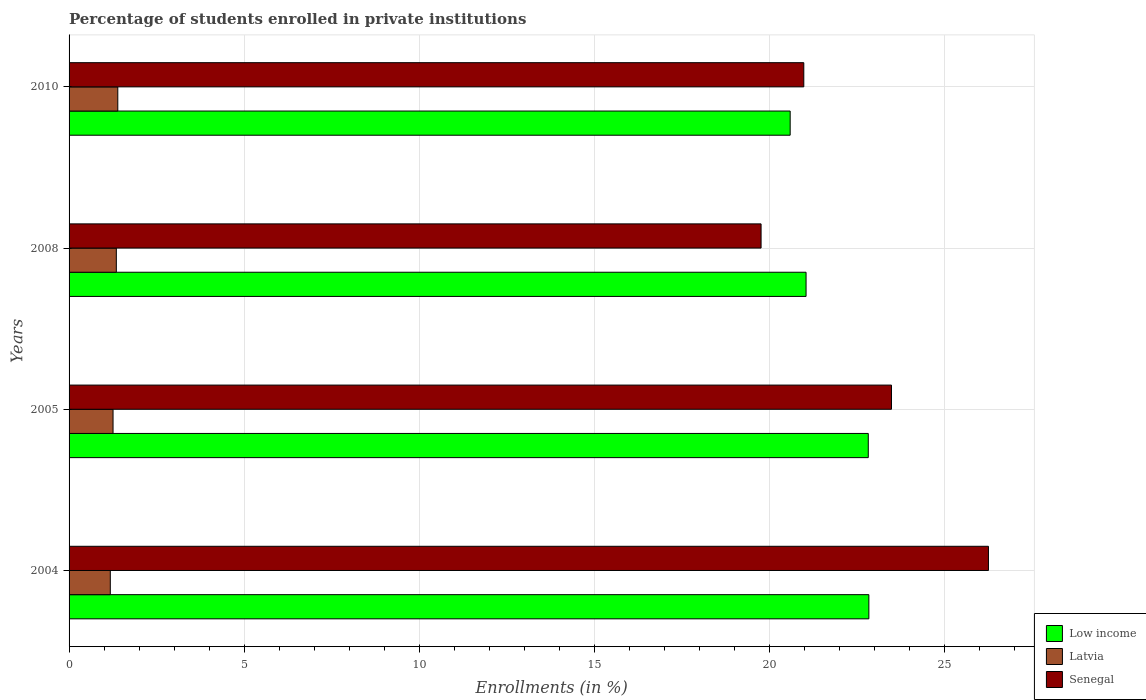How many groups of bars are there?
Offer a terse response. 4. Are the number of bars per tick equal to the number of legend labels?
Ensure brevity in your answer.  Yes. Are the number of bars on each tick of the Y-axis equal?
Offer a very short reply. Yes. What is the label of the 3rd group of bars from the top?
Provide a short and direct response. 2005. What is the percentage of trained teachers in Low income in 2008?
Your response must be concise. 21.04. Across all years, what is the maximum percentage of trained teachers in Low income?
Make the answer very short. 22.83. Across all years, what is the minimum percentage of trained teachers in Low income?
Offer a terse response. 20.59. What is the total percentage of trained teachers in Senegal in the graph?
Your answer should be compact. 90.46. What is the difference between the percentage of trained teachers in Latvia in 2004 and that in 2010?
Provide a succinct answer. -0.21. What is the difference between the percentage of trained teachers in Senegal in 2005 and the percentage of trained teachers in Low income in 2008?
Your answer should be very brief. 2.44. What is the average percentage of trained teachers in Senegal per year?
Your answer should be compact. 22.61. In the year 2005, what is the difference between the percentage of trained teachers in Low income and percentage of trained teachers in Senegal?
Provide a short and direct response. -0.66. What is the ratio of the percentage of trained teachers in Low income in 2005 to that in 2008?
Your answer should be very brief. 1.08. Is the difference between the percentage of trained teachers in Low income in 2004 and 2008 greater than the difference between the percentage of trained teachers in Senegal in 2004 and 2008?
Offer a very short reply. No. What is the difference between the highest and the second highest percentage of trained teachers in Senegal?
Make the answer very short. 2.77. What is the difference between the highest and the lowest percentage of trained teachers in Low income?
Your answer should be very brief. 2.25. What does the 3rd bar from the bottom in 2005 represents?
Your answer should be compact. Senegal. Is it the case that in every year, the sum of the percentage of trained teachers in Senegal and percentage of trained teachers in Latvia is greater than the percentage of trained teachers in Low income?
Provide a succinct answer. Yes. How many years are there in the graph?
Offer a very short reply. 4. What is the difference between two consecutive major ticks on the X-axis?
Ensure brevity in your answer.  5. Are the values on the major ticks of X-axis written in scientific E-notation?
Ensure brevity in your answer.  No. Does the graph contain any zero values?
Offer a very short reply. No. Does the graph contain grids?
Provide a succinct answer. Yes. What is the title of the graph?
Offer a terse response. Percentage of students enrolled in private institutions. What is the label or title of the X-axis?
Give a very brief answer. Enrollments (in %). What is the Enrollments (in %) in Low income in 2004?
Ensure brevity in your answer.  22.83. What is the Enrollments (in %) of Latvia in 2004?
Provide a short and direct response. 1.18. What is the Enrollments (in %) in Senegal in 2004?
Provide a short and direct response. 26.25. What is the Enrollments (in %) of Low income in 2005?
Offer a very short reply. 22.82. What is the Enrollments (in %) in Latvia in 2005?
Your response must be concise. 1.26. What is the Enrollments (in %) in Senegal in 2005?
Your response must be concise. 23.48. What is the Enrollments (in %) of Low income in 2008?
Make the answer very short. 21.04. What is the Enrollments (in %) of Latvia in 2008?
Offer a very short reply. 1.35. What is the Enrollments (in %) in Senegal in 2008?
Your answer should be very brief. 19.76. What is the Enrollments (in %) in Low income in 2010?
Offer a very short reply. 20.59. What is the Enrollments (in %) in Latvia in 2010?
Give a very brief answer. 1.39. What is the Enrollments (in %) in Senegal in 2010?
Your response must be concise. 20.98. Across all years, what is the maximum Enrollments (in %) in Low income?
Your answer should be compact. 22.83. Across all years, what is the maximum Enrollments (in %) in Latvia?
Your answer should be compact. 1.39. Across all years, what is the maximum Enrollments (in %) in Senegal?
Provide a succinct answer. 26.25. Across all years, what is the minimum Enrollments (in %) in Low income?
Provide a succinct answer. 20.59. Across all years, what is the minimum Enrollments (in %) of Latvia?
Your answer should be compact. 1.18. Across all years, what is the minimum Enrollments (in %) in Senegal?
Ensure brevity in your answer.  19.76. What is the total Enrollments (in %) of Low income in the graph?
Keep it short and to the point. 87.28. What is the total Enrollments (in %) in Latvia in the graph?
Provide a short and direct response. 5.17. What is the total Enrollments (in %) of Senegal in the graph?
Provide a short and direct response. 90.46. What is the difference between the Enrollments (in %) of Low income in 2004 and that in 2005?
Make the answer very short. 0.02. What is the difference between the Enrollments (in %) in Latvia in 2004 and that in 2005?
Offer a terse response. -0.08. What is the difference between the Enrollments (in %) in Senegal in 2004 and that in 2005?
Provide a succinct answer. 2.77. What is the difference between the Enrollments (in %) in Low income in 2004 and that in 2008?
Provide a succinct answer. 1.79. What is the difference between the Enrollments (in %) in Latvia in 2004 and that in 2008?
Offer a terse response. -0.17. What is the difference between the Enrollments (in %) in Senegal in 2004 and that in 2008?
Keep it short and to the point. 6.49. What is the difference between the Enrollments (in %) in Low income in 2004 and that in 2010?
Give a very brief answer. 2.25. What is the difference between the Enrollments (in %) of Latvia in 2004 and that in 2010?
Your answer should be very brief. -0.21. What is the difference between the Enrollments (in %) in Senegal in 2004 and that in 2010?
Provide a short and direct response. 5.27. What is the difference between the Enrollments (in %) of Low income in 2005 and that in 2008?
Keep it short and to the point. 1.78. What is the difference between the Enrollments (in %) in Latvia in 2005 and that in 2008?
Your answer should be compact. -0.09. What is the difference between the Enrollments (in %) of Senegal in 2005 and that in 2008?
Give a very brief answer. 3.72. What is the difference between the Enrollments (in %) of Low income in 2005 and that in 2010?
Offer a very short reply. 2.23. What is the difference between the Enrollments (in %) of Latvia in 2005 and that in 2010?
Provide a short and direct response. -0.14. What is the difference between the Enrollments (in %) of Senegal in 2005 and that in 2010?
Your answer should be very brief. 2.5. What is the difference between the Enrollments (in %) of Low income in 2008 and that in 2010?
Give a very brief answer. 0.45. What is the difference between the Enrollments (in %) of Latvia in 2008 and that in 2010?
Your answer should be very brief. -0.04. What is the difference between the Enrollments (in %) of Senegal in 2008 and that in 2010?
Offer a terse response. -1.22. What is the difference between the Enrollments (in %) of Low income in 2004 and the Enrollments (in %) of Latvia in 2005?
Provide a short and direct response. 21.58. What is the difference between the Enrollments (in %) in Low income in 2004 and the Enrollments (in %) in Senegal in 2005?
Provide a succinct answer. -0.65. What is the difference between the Enrollments (in %) of Latvia in 2004 and the Enrollments (in %) of Senegal in 2005?
Your response must be concise. -22.3. What is the difference between the Enrollments (in %) of Low income in 2004 and the Enrollments (in %) of Latvia in 2008?
Provide a succinct answer. 21.48. What is the difference between the Enrollments (in %) of Low income in 2004 and the Enrollments (in %) of Senegal in 2008?
Your answer should be very brief. 3.08. What is the difference between the Enrollments (in %) of Latvia in 2004 and the Enrollments (in %) of Senegal in 2008?
Provide a short and direct response. -18.58. What is the difference between the Enrollments (in %) of Low income in 2004 and the Enrollments (in %) of Latvia in 2010?
Your answer should be very brief. 21.44. What is the difference between the Enrollments (in %) in Low income in 2004 and the Enrollments (in %) in Senegal in 2010?
Give a very brief answer. 1.86. What is the difference between the Enrollments (in %) of Latvia in 2004 and the Enrollments (in %) of Senegal in 2010?
Keep it short and to the point. -19.8. What is the difference between the Enrollments (in %) in Low income in 2005 and the Enrollments (in %) in Latvia in 2008?
Your response must be concise. 21.47. What is the difference between the Enrollments (in %) of Low income in 2005 and the Enrollments (in %) of Senegal in 2008?
Provide a succinct answer. 3.06. What is the difference between the Enrollments (in %) in Latvia in 2005 and the Enrollments (in %) in Senegal in 2008?
Your answer should be very brief. -18.5. What is the difference between the Enrollments (in %) of Low income in 2005 and the Enrollments (in %) of Latvia in 2010?
Offer a terse response. 21.43. What is the difference between the Enrollments (in %) of Low income in 2005 and the Enrollments (in %) of Senegal in 2010?
Provide a succinct answer. 1.84. What is the difference between the Enrollments (in %) in Latvia in 2005 and the Enrollments (in %) in Senegal in 2010?
Ensure brevity in your answer.  -19.72. What is the difference between the Enrollments (in %) of Low income in 2008 and the Enrollments (in %) of Latvia in 2010?
Keep it short and to the point. 19.65. What is the difference between the Enrollments (in %) in Low income in 2008 and the Enrollments (in %) in Senegal in 2010?
Your answer should be compact. 0.06. What is the difference between the Enrollments (in %) of Latvia in 2008 and the Enrollments (in %) of Senegal in 2010?
Give a very brief answer. -19.63. What is the average Enrollments (in %) of Low income per year?
Provide a succinct answer. 21.82. What is the average Enrollments (in %) of Latvia per year?
Make the answer very short. 1.29. What is the average Enrollments (in %) in Senegal per year?
Provide a succinct answer. 22.61. In the year 2004, what is the difference between the Enrollments (in %) in Low income and Enrollments (in %) in Latvia?
Offer a very short reply. 21.66. In the year 2004, what is the difference between the Enrollments (in %) of Low income and Enrollments (in %) of Senegal?
Keep it short and to the point. -3.41. In the year 2004, what is the difference between the Enrollments (in %) in Latvia and Enrollments (in %) in Senegal?
Your answer should be very brief. -25.07. In the year 2005, what is the difference between the Enrollments (in %) of Low income and Enrollments (in %) of Latvia?
Your answer should be compact. 21.56. In the year 2005, what is the difference between the Enrollments (in %) in Low income and Enrollments (in %) in Senegal?
Ensure brevity in your answer.  -0.66. In the year 2005, what is the difference between the Enrollments (in %) of Latvia and Enrollments (in %) of Senegal?
Offer a very short reply. -22.22. In the year 2008, what is the difference between the Enrollments (in %) in Low income and Enrollments (in %) in Latvia?
Offer a terse response. 19.69. In the year 2008, what is the difference between the Enrollments (in %) of Low income and Enrollments (in %) of Senegal?
Ensure brevity in your answer.  1.28. In the year 2008, what is the difference between the Enrollments (in %) in Latvia and Enrollments (in %) in Senegal?
Provide a short and direct response. -18.41. In the year 2010, what is the difference between the Enrollments (in %) of Low income and Enrollments (in %) of Latvia?
Ensure brevity in your answer.  19.2. In the year 2010, what is the difference between the Enrollments (in %) in Low income and Enrollments (in %) in Senegal?
Provide a succinct answer. -0.39. In the year 2010, what is the difference between the Enrollments (in %) in Latvia and Enrollments (in %) in Senegal?
Offer a terse response. -19.58. What is the ratio of the Enrollments (in %) in Latvia in 2004 to that in 2005?
Your response must be concise. 0.94. What is the ratio of the Enrollments (in %) in Senegal in 2004 to that in 2005?
Give a very brief answer. 1.12. What is the ratio of the Enrollments (in %) of Low income in 2004 to that in 2008?
Keep it short and to the point. 1.09. What is the ratio of the Enrollments (in %) of Latvia in 2004 to that in 2008?
Offer a very short reply. 0.87. What is the ratio of the Enrollments (in %) in Senegal in 2004 to that in 2008?
Keep it short and to the point. 1.33. What is the ratio of the Enrollments (in %) of Low income in 2004 to that in 2010?
Your answer should be compact. 1.11. What is the ratio of the Enrollments (in %) in Latvia in 2004 to that in 2010?
Your response must be concise. 0.85. What is the ratio of the Enrollments (in %) in Senegal in 2004 to that in 2010?
Provide a succinct answer. 1.25. What is the ratio of the Enrollments (in %) of Low income in 2005 to that in 2008?
Offer a terse response. 1.08. What is the ratio of the Enrollments (in %) in Latvia in 2005 to that in 2008?
Offer a terse response. 0.93. What is the ratio of the Enrollments (in %) of Senegal in 2005 to that in 2008?
Your response must be concise. 1.19. What is the ratio of the Enrollments (in %) of Low income in 2005 to that in 2010?
Your answer should be compact. 1.11. What is the ratio of the Enrollments (in %) of Latvia in 2005 to that in 2010?
Keep it short and to the point. 0.9. What is the ratio of the Enrollments (in %) in Senegal in 2005 to that in 2010?
Give a very brief answer. 1.12. What is the ratio of the Enrollments (in %) in Low income in 2008 to that in 2010?
Your answer should be very brief. 1.02. What is the ratio of the Enrollments (in %) of Latvia in 2008 to that in 2010?
Give a very brief answer. 0.97. What is the ratio of the Enrollments (in %) of Senegal in 2008 to that in 2010?
Provide a succinct answer. 0.94. What is the difference between the highest and the second highest Enrollments (in %) of Low income?
Keep it short and to the point. 0.02. What is the difference between the highest and the second highest Enrollments (in %) in Latvia?
Make the answer very short. 0.04. What is the difference between the highest and the second highest Enrollments (in %) of Senegal?
Provide a succinct answer. 2.77. What is the difference between the highest and the lowest Enrollments (in %) in Low income?
Give a very brief answer. 2.25. What is the difference between the highest and the lowest Enrollments (in %) in Latvia?
Keep it short and to the point. 0.21. What is the difference between the highest and the lowest Enrollments (in %) in Senegal?
Provide a succinct answer. 6.49. 